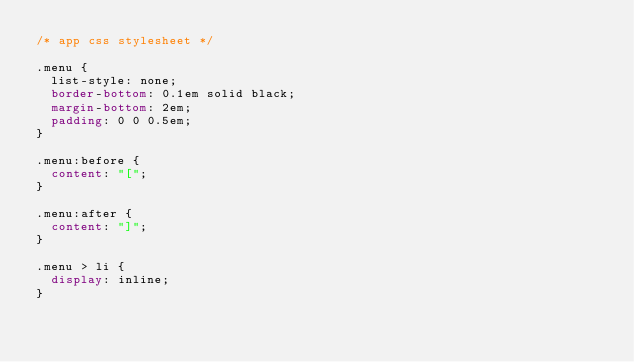Convert code to text. <code><loc_0><loc_0><loc_500><loc_500><_CSS_>/* app css stylesheet */

.menu {
  list-style: none;
  border-bottom: 0.1em solid black;
  margin-bottom: 2em;
  padding: 0 0 0.5em;
}

.menu:before {
  content: "[";
}

.menu:after {
  content: "]";
}

.menu > li {
  display: inline;
}
</code> 